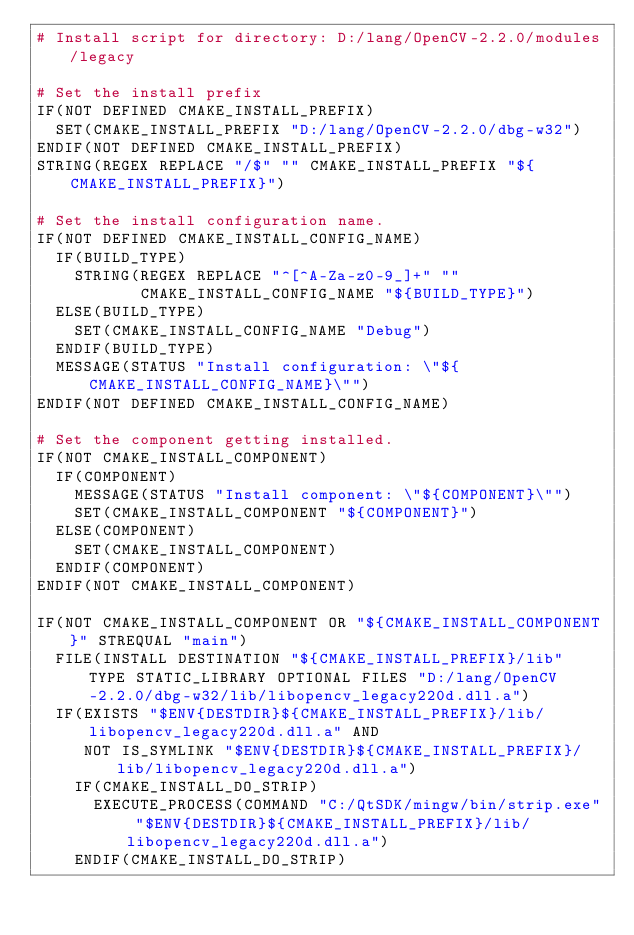<code> <loc_0><loc_0><loc_500><loc_500><_CMake_># Install script for directory: D:/lang/OpenCV-2.2.0/modules/legacy

# Set the install prefix
IF(NOT DEFINED CMAKE_INSTALL_PREFIX)
  SET(CMAKE_INSTALL_PREFIX "D:/lang/OpenCV-2.2.0/dbg-w32")
ENDIF(NOT DEFINED CMAKE_INSTALL_PREFIX)
STRING(REGEX REPLACE "/$" "" CMAKE_INSTALL_PREFIX "${CMAKE_INSTALL_PREFIX}")

# Set the install configuration name.
IF(NOT DEFINED CMAKE_INSTALL_CONFIG_NAME)
  IF(BUILD_TYPE)
    STRING(REGEX REPLACE "^[^A-Za-z0-9_]+" ""
           CMAKE_INSTALL_CONFIG_NAME "${BUILD_TYPE}")
  ELSE(BUILD_TYPE)
    SET(CMAKE_INSTALL_CONFIG_NAME "Debug")
  ENDIF(BUILD_TYPE)
  MESSAGE(STATUS "Install configuration: \"${CMAKE_INSTALL_CONFIG_NAME}\"")
ENDIF(NOT DEFINED CMAKE_INSTALL_CONFIG_NAME)

# Set the component getting installed.
IF(NOT CMAKE_INSTALL_COMPONENT)
  IF(COMPONENT)
    MESSAGE(STATUS "Install component: \"${COMPONENT}\"")
    SET(CMAKE_INSTALL_COMPONENT "${COMPONENT}")
  ELSE(COMPONENT)
    SET(CMAKE_INSTALL_COMPONENT)
  ENDIF(COMPONENT)
ENDIF(NOT CMAKE_INSTALL_COMPONENT)

IF(NOT CMAKE_INSTALL_COMPONENT OR "${CMAKE_INSTALL_COMPONENT}" STREQUAL "main")
  FILE(INSTALL DESTINATION "${CMAKE_INSTALL_PREFIX}/lib" TYPE STATIC_LIBRARY OPTIONAL FILES "D:/lang/OpenCV-2.2.0/dbg-w32/lib/libopencv_legacy220d.dll.a")
  IF(EXISTS "$ENV{DESTDIR}${CMAKE_INSTALL_PREFIX}/lib/libopencv_legacy220d.dll.a" AND
     NOT IS_SYMLINK "$ENV{DESTDIR}${CMAKE_INSTALL_PREFIX}/lib/libopencv_legacy220d.dll.a")
    IF(CMAKE_INSTALL_DO_STRIP)
      EXECUTE_PROCESS(COMMAND "C:/QtSDK/mingw/bin/strip.exe" "$ENV{DESTDIR}${CMAKE_INSTALL_PREFIX}/lib/libopencv_legacy220d.dll.a")
    ENDIF(CMAKE_INSTALL_DO_STRIP)</code> 